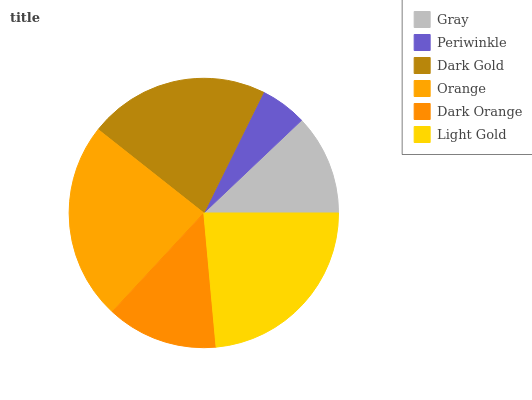Is Periwinkle the minimum?
Answer yes or no. Yes. Is Orange the maximum?
Answer yes or no. Yes. Is Dark Gold the minimum?
Answer yes or no. No. Is Dark Gold the maximum?
Answer yes or no. No. Is Dark Gold greater than Periwinkle?
Answer yes or no. Yes. Is Periwinkle less than Dark Gold?
Answer yes or no. Yes. Is Periwinkle greater than Dark Gold?
Answer yes or no. No. Is Dark Gold less than Periwinkle?
Answer yes or no. No. Is Dark Gold the high median?
Answer yes or no. Yes. Is Dark Orange the low median?
Answer yes or no. Yes. Is Gray the high median?
Answer yes or no. No. Is Light Gold the low median?
Answer yes or no. No. 